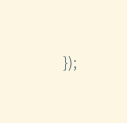<code> <loc_0><loc_0><loc_500><loc_500><_JavaScript_>    });

</code> 